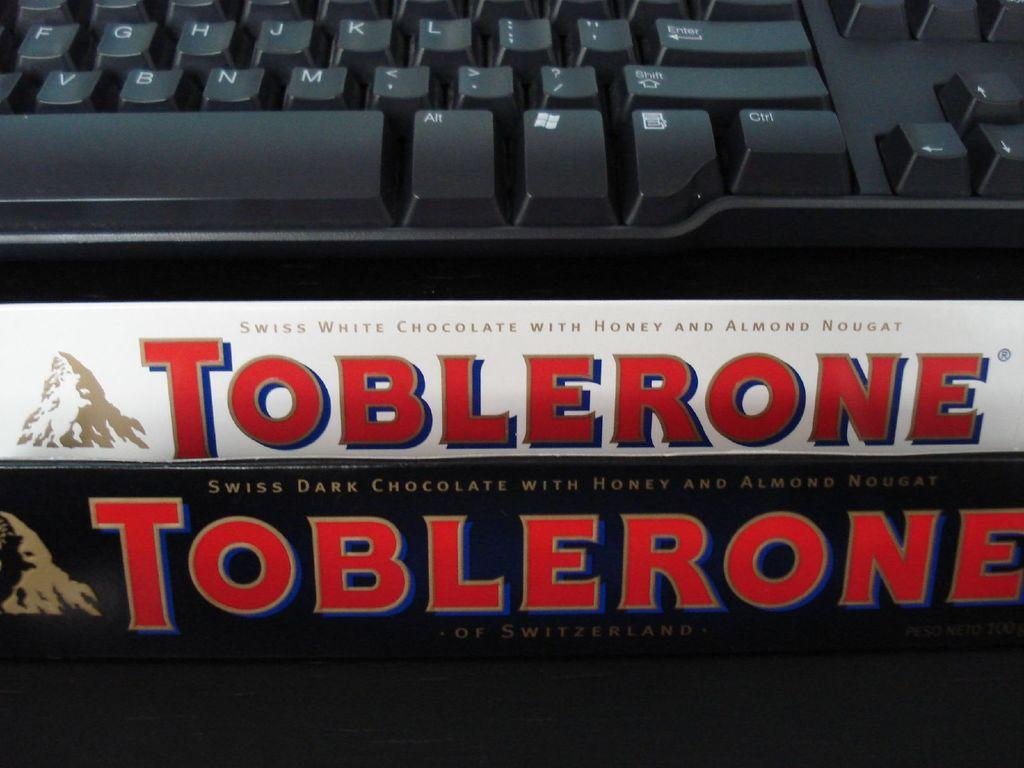What is the main object in the image? There is a keyboard in the image. What else can be seen at the bottom of the image? There is a poster with text and images at the bottom of the image. How does the frog perform magic tricks on the keyboard in the image? There is no frog or magic tricks present in the image; it only features a keyboard and a poster. 